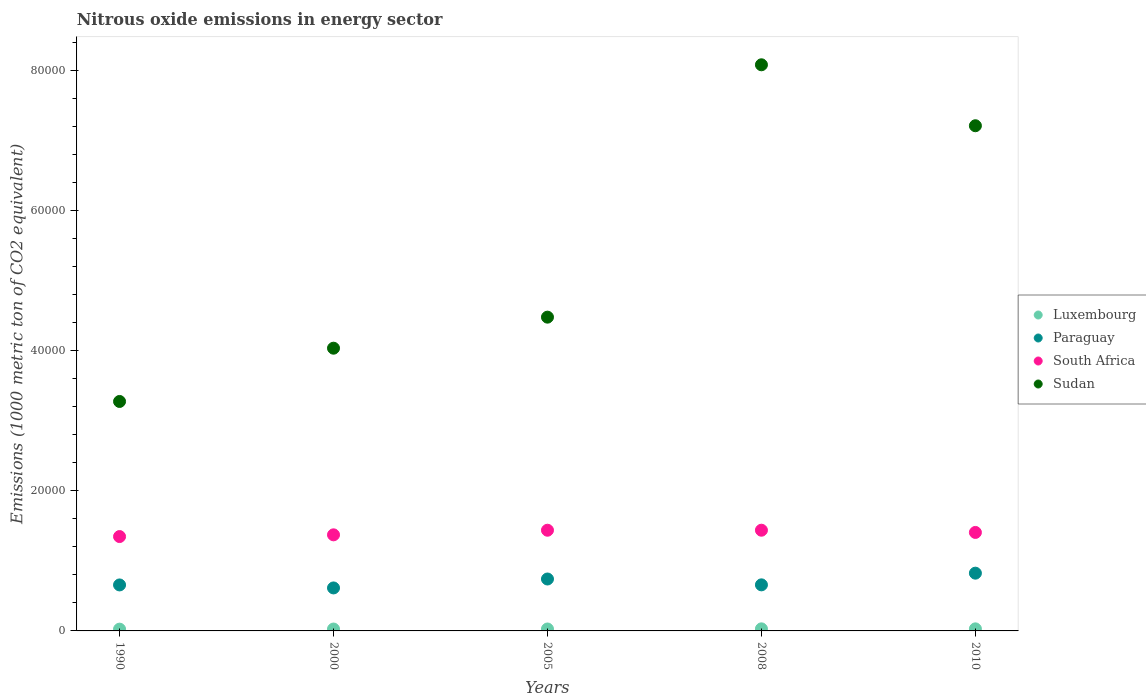Is the number of dotlines equal to the number of legend labels?
Provide a succinct answer. Yes. What is the amount of nitrous oxide emitted in Paraguay in 2010?
Provide a succinct answer. 8239.6. Across all years, what is the maximum amount of nitrous oxide emitted in Sudan?
Offer a very short reply. 8.08e+04. Across all years, what is the minimum amount of nitrous oxide emitted in South Africa?
Your answer should be very brief. 1.35e+04. What is the total amount of nitrous oxide emitted in South Africa in the graph?
Offer a terse response. 7.00e+04. What is the difference between the amount of nitrous oxide emitted in South Africa in 2005 and that in 2010?
Ensure brevity in your answer.  315.5. What is the difference between the amount of nitrous oxide emitted in Paraguay in 2005 and the amount of nitrous oxide emitted in Luxembourg in 2010?
Keep it short and to the point. 7113.5. What is the average amount of nitrous oxide emitted in Paraguay per year?
Your answer should be compact. 6982.86. In the year 1990, what is the difference between the amount of nitrous oxide emitted in South Africa and amount of nitrous oxide emitted in Sudan?
Offer a very short reply. -1.93e+04. What is the ratio of the amount of nitrous oxide emitted in Sudan in 1990 to that in 2010?
Offer a very short reply. 0.45. Is the difference between the amount of nitrous oxide emitted in South Africa in 2000 and 2010 greater than the difference between the amount of nitrous oxide emitted in Sudan in 2000 and 2010?
Make the answer very short. Yes. What is the difference between the highest and the second highest amount of nitrous oxide emitted in Luxembourg?
Your answer should be compact. 2. What is the difference between the highest and the lowest amount of nitrous oxide emitted in Paraguay?
Offer a terse response. 2106.8. In how many years, is the amount of nitrous oxide emitted in South Africa greater than the average amount of nitrous oxide emitted in South Africa taken over all years?
Your answer should be compact. 3. Is the sum of the amount of nitrous oxide emitted in Luxembourg in 2000 and 2005 greater than the maximum amount of nitrous oxide emitted in Sudan across all years?
Offer a terse response. No. Does the amount of nitrous oxide emitted in Luxembourg monotonically increase over the years?
Your answer should be compact. No. How many dotlines are there?
Provide a succinct answer. 4. Does the graph contain any zero values?
Your answer should be compact. No. Does the graph contain grids?
Ensure brevity in your answer.  No. Where does the legend appear in the graph?
Your response must be concise. Center right. How many legend labels are there?
Your answer should be very brief. 4. How are the legend labels stacked?
Make the answer very short. Vertical. What is the title of the graph?
Give a very brief answer. Nitrous oxide emissions in energy sector. Does "Middle East & North Africa (all income levels)" appear as one of the legend labels in the graph?
Your response must be concise. No. What is the label or title of the X-axis?
Give a very brief answer. Years. What is the label or title of the Y-axis?
Provide a short and direct response. Emissions (1000 metric ton of CO2 equivalent). What is the Emissions (1000 metric ton of CO2 equivalent) in Luxembourg in 1990?
Make the answer very short. 253.6. What is the Emissions (1000 metric ton of CO2 equivalent) of Paraguay in 1990?
Ensure brevity in your answer.  6561.2. What is the Emissions (1000 metric ton of CO2 equivalent) in South Africa in 1990?
Make the answer very short. 1.35e+04. What is the Emissions (1000 metric ton of CO2 equivalent) in Sudan in 1990?
Your response must be concise. 3.27e+04. What is the Emissions (1000 metric ton of CO2 equivalent) of Luxembourg in 2000?
Your answer should be compact. 268.4. What is the Emissions (1000 metric ton of CO2 equivalent) of Paraguay in 2000?
Your answer should be very brief. 6132.8. What is the Emissions (1000 metric ton of CO2 equivalent) in South Africa in 2000?
Offer a terse response. 1.37e+04. What is the Emissions (1000 metric ton of CO2 equivalent) in Sudan in 2000?
Your answer should be very brief. 4.03e+04. What is the Emissions (1000 metric ton of CO2 equivalent) in Luxembourg in 2005?
Offer a very short reply. 275.3. What is the Emissions (1000 metric ton of CO2 equivalent) of Paraguay in 2005?
Keep it short and to the point. 7407.7. What is the Emissions (1000 metric ton of CO2 equivalent) of South Africa in 2005?
Ensure brevity in your answer.  1.44e+04. What is the Emissions (1000 metric ton of CO2 equivalent) in Sudan in 2005?
Your response must be concise. 4.48e+04. What is the Emissions (1000 metric ton of CO2 equivalent) of Luxembourg in 2008?
Ensure brevity in your answer.  296.2. What is the Emissions (1000 metric ton of CO2 equivalent) in Paraguay in 2008?
Provide a succinct answer. 6573. What is the Emissions (1000 metric ton of CO2 equivalent) of South Africa in 2008?
Keep it short and to the point. 1.44e+04. What is the Emissions (1000 metric ton of CO2 equivalent) of Sudan in 2008?
Provide a succinct answer. 8.08e+04. What is the Emissions (1000 metric ton of CO2 equivalent) of Luxembourg in 2010?
Offer a terse response. 294.2. What is the Emissions (1000 metric ton of CO2 equivalent) in Paraguay in 2010?
Your answer should be very brief. 8239.6. What is the Emissions (1000 metric ton of CO2 equivalent) of South Africa in 2010?
Provide a succinct answer. 1.41e+04. What is the Emissions (1000 metric ton of CO2 equivalent) of Sudan in 2010?
Provide a succinct answer. 7.21e+04. Across all years, what is the maximum Emissions (1000 metric ton of CO2 equivalent) of Luxembourg?
Your answer should be very brief. 296.2. Across all years, what is the maximum Emissions (1000 metric ton of CO2 equivalent) of Paraguay?
Provide a short and direct response. 8239.6. Across all years, what is the maximum Emissions (1000 metric ton of CO2 equivalent) in South Africa?
Provide a succinct answer. 1.44e+04. Across all years, what is the maximum Emissions (1000 metric ton of CO2 equivalent) of Sudan?
Make the answer very short. 8.08e+04. Across all years, what is the minimum Emissions (1000 metric ton of CO2 equivalent) in Luxembourg?
Give a very brief answer. 253.6. Across all years, what is the minimum Emissions (1000 metric ton of CO2 equivalent) in Paraguay?
Your answer should be very brief. 6132.8. Across all years, what is the minimum Emissions (1000 metric ton of CO2 equivalent) of South Africa?
Offer a very short reply. 1.35e+04. Across all years, what is the minimum Emissions (1000 metric ton of CO2 equivalent) of Sudan?
Your answer should be very brief. 3.27e+04. What is the total Emissions (1000 metric ton of CO2 equivalent) of Luxembourg in the graph?
Your answer should be very brief. 1387.7. What is the total Emissions (1000 metric ton of CO2 equivalent) in Paraguay in the graph?
Ensure brevity in your answer.  3.49e+04. What is the total Emissions (1000 metric ton of CO2 equivalent) in South Africa in the graph?
Offer a terse response. 7.00e+04. What is the total Emissions (1000 metric ton of CO2 equivalent) in Sudan in the graph?
Give a very brief answer. 2.71e+05. What is the difference between the Emissions (1000 metric ton of CO2 equivalent) of Luxembourg in 1990 and that in 2000?
Provide a succinct answer. -14.8. What is the difference between the Emissions (1000 metric ton of CO2 equivalent) of Paraguay in 1990 and that in 2000?
Keep it short and to the point. 428.4. What is the difference between the Emissions (1000 metric ton of CO2 equivalent) of South Africa in 1990 and that in 2000?
Offer a terse response. -246.5. What is the difference between the Emissions (1000 metric ton of CO2 equivalent) of Sudan in 1990 and that in 2000?
Your response must be concise. -7600.6. What is the difference between the Emissions (1000 metric ton of CO2 equivalent) of Luxembourg in 1990 and that in 2005?
Your answer should be compact. -21.7. What is the difference between the Emissions (1000 metric ton of CO2 equivalent) of Paraguay in 1990 and that in 2005?
Provide a succinct answer. -846.5. What is the difference between the Emissions (1000 metric ton of CO2 equivalent) of South Africa in 1990 and that in 2005?
Provide a short and direct response. -903.7. What is the difference between the Emissions (1000 metric ton of CO2 equivalent) of Sudan in 1990 and that in 2005?
Keep it short and to the point. -1.20e+04. What is the difference between the Emissions (1000 metric ton of CO2 equivalent) in Luxembourg in 1990 and that in 2008?
Provide a succinct answer. -42.6. What is the difference between the Emissions (1000 metric ton of CO2 equivalent) in South Africa in 1990 and that in 2008?
Offer a very short reply. -905.7. What is the difference between the Emissions (1000 metric ton of CO2 equivalent) in Sudan in 1990 and that in 2008?
Your answer should be very brief. -4.80e+04. What is the difference between the Emissions (1000 metric ton of CO2 equivalent) in Luxembourg in 1990 and that in 2010?
Ensure brevity in your answer.  -40.6. What is the difference between the Emissions (1000 metric ton of CO2 equivalent) in Paraguay in 1990 and that in 2010?
Offer a very short reply. -1678.4. What is the difference between the Emissions (1000 metric ton of CO2 equivalent) in South Africa in 1990 and that in 2010?
Offer a very short reply. -588.2. What is the difference between the Emissions (1000 metric ton of CO2 equivalent) in Sudan in 1990 and that in 2010?
Provide a short and direct response. -3.93e+04. What is the difference between the Emissions (1000 metric ton of CO2 equivalent) in Luxembourg in 2000 and that in 2005?
Give a very brief answer. -6.9. What is the difference between the Emissions (1000 metric ton of CO2 equivalent) in Paraguay in 2000 and that in 2005?
Offer a very short reply. -1274.9. What is the difference between the Emissions (1000 metric ton of CO2 equivalent) in South Africa in 2000 and that in 2005?
Offer a very short reply. -657.2. What is the difference between the Emissions (1000 metric ton of CO2 equivalent) in Sudan in 2000 and that in 2005?
Give a very brief answer. -4429.1. What is the difference between the Emissions (1000 metric ton of CO2 equivalent) in Luxembourg in 2000 and that in 2008?
Offer a very short reply. -27.8. What is the difference between the Emissions (1000 metric ton of CO2 equivalent) in Paraguay in 2000 and that in 2008?
Provide a succinct answer. -440.2. What is the difference between the Emissions (1000 metric ton of CO2 equivalent) in South Africa in 2000 and that in 2008?
Your answer should be compact. -659.2. What is the difference between the Emissions (1000 metric ton of CO2 equivalent) of Sudan in 2000 and that in 2008?
Offer a very short reply. -4.04e+04. What is the difference between the Emissions (1000 metric ton of CO2 equivalent) of Luxembourg in 2000 and that in 2010?
Make the answer very short. -25.8. What is the difference between the Emissions (1000 metric ton of CO2 equivalent) in Paraguay in 2000 and that in 2010?
Keep it short and to the point. -2106.8. What is the difference between the Emissions (1000 metric ton of CO2 equivalent) of South Africa in 2000 and that in 2010?
Your answer should be compact. -341.7. What is the difference between the Emissions (1000 metric ton of CO2 equivalent) of Sudan in 2000 and that in 2010?
Make the answer very short. -3.17e+04. What is the difference between the Emissions (1000 metric ton of CO2 equivalent) of Luxembourg in 2005 and that in 2008?
Provide a succinct answer. -20.9. What is the difference between the Emissions (1000 metric ton of CO2 equivalent) in Paraguay in 2005 and that in 2008?
Ensure brevity in your answer.  834.7. What is the difference between the Emissions (1000 metric ton of CO2 equivalent) in South Africa in 2005 and that in 2008?
Make the answer very short. -2. What is the difference between the Emissions (1000 metric ton of CO2 equivalent) in Sudan in 2005 and that in 2008?
Make the answer very short. -3.60e+04. What is the difference between the Emissions (1000 metric ton of CO2 equivalent) of Luxembourg in 2005 and that in 2010?
Make the answer very short. -18.9. What is the difference between the Emissions (1000 metric ton of CO2 equivalent) in Paraguay in 2005 and that in 2010?
Make the answer very short. -831.9. What is the difference between the Emissions (1000 metric ton of CO2 equivalent) in South Africa in 2005 and that in 2010?
Make the answer very short. 315.5. What is the difference between the Emissions (1000 metric ton of CO2 equivalent) of Sudan in 2005 and that in 2010?
Give a very brief answer. -2.73e+04. What is the difference between the Emissions (1000 metric ton of CO2 equivalent) in Paraguay in 2008 and that in 2010?
Ensure brevity in your answer.  -1666.6. What is the difference between the Emissions (1000 metric ton of CO2 equivalent) of South Africa in 2008 and that in 2010?
Offer a terse response. 317.5. What is the difference between the Emissions (1000 metric ton of CO2 equivalent) in Sudan in 2008 and that in 2010?
Your answer should be compact. 8696.2. What is the difference between the Emissions (1000 metric ton of CO2 equivalent) in Luxembourg in 1990 and the Emissions (1000 metric ton of CO2 equivalent) in Paraguay in 2000?
Your response must be concise. -5879.2. What is the difference between the Emissions (1000 metric ton of CO2 equivalent) in Luxembourg in 1990 and the Emissions (1000 metric ton of CO2 equivalent) in South Africa in 2000?
Offer a very short reply. -1.35e+04. What is the difference between the Emissions (1000 metric ton of CO2 equivalent) of Luxembourg in 1990 and the Emissions (1000 metric ton of CO2 equivalent) of Sudan in 2000?
Provide a short and direct response. -4.01e+04. What is the difference between the Emissions (1000 metric ton of CO2 equivalent) of Paraguay in 1990 and the Emissions (1000 metric ton of CO2 equivalent) of South Africa in 2000?
Provide a succinct answer. -7148.7. What is the difference between the Emissions (1000 metric ton of CO2 equivalent) in Paraguay in 1990 and the Emissions (1000 metric ton of CO2 equivalent) in Sudan in 2000?
Your answer should be very brief. -3.38e+04. What is the difference between the Emissions (1000 metric ton of CO2 equivalent) of South Africa in 1990 and the Emissions (1000 metric ton of CO2 equivalent) of Sudan in 2000?
Your answer should be very brief. -2.69e+04. What is the difference between the Emissions (1000 metric ton of CO2 equivalent) of Luxembourg in 1990 and the Emissions (1000 metric ton of CO2 equivalent) of Paraguay in 2005?
Your response must be concise. -7154.1. What is the difference between the Emissions (1000 metric ton of CO2 equivalent) of Luxembourg in 1990 and the Emissions (1000 metric ton of CO2 equivalent) of South Africa in 2005?
Offer a very short reply. -1.41e+04. What is the difference between the Emissions (1000 metric ton of CO2 equivalent) in Luxembourg in 1990 and the Emissions (1000 metric ton of CO2 equivalent) in Sudan in 2005?
Keep it short and to the point. -4.45e+04. What is the difference between the Emissions (1000 metric ton of CO2 equivalent) in Paraguay in 1990 and the Emissions (1000 metric ton of CO2 equivalent) in South Africa in 2005?
Ensure brevity in your answer.  -7805.9. What is the difference between the Emissions (1000 metric ton of CO2 equivalent) in Paraguay in 1990 and the Emissions (1000 metric ton of CO2 equivalent) in Sudan in 2005?
Offer a terse response. -3.82e+04. What is the difference between the Emissions (1000 metric ton of CO2 equivalent) in South Africa in 1990 and the Emissions (1000 metric ton of CO2 equivalent) in Sudan in 2005?
Offer a very short reply. -3.13e+04. What is the difference between the Emissions (1000 metric ton of CO2 equivalent) in Luxembourg in 1990 and the Emissions (1000 metric ton of CO2 equivalent) in Paraguay in 2008?
Provide a succinct answer. -6319.4. What is the difference between the Emissions (1000 metric ton of CO2 equivalent) of Luxembourg in 1990 and the Emissions (1000 metric ton of CO2 equivalent) of South Africa in 2008?
Provide a short and direct response. -1.41e+04. What is the difference between the Emissions (1000 metric ton of CO2 equivalent) of Luxembourg in 1990 and the Emissions (1000 metric ton of CO2 equivalent) of Sudan in 2008?
Make the answer very short. -8.05e+04. What is the difference between the Emissions (1000 metric ton of CO2 equivalent) of Paraguay in 1990 and the Emissions (1000 metric ton of CO2 equivalent) of South Africa in 2008?
Your response must be concise. -7807.9. What is the difference between the Emissions (1000 metric ton of CO2 equivalent) in Paraguay in 1990 and the Emissions (1000 metric ton of CO2 equivalent) in Sudan in 2008?
Offer a terse response. -7.42e+04. What is the difference between the Emissions (1000 metric ton of CO2 equivalent) of South Africa in 1990 and the Emissions (1000 metric ton of CO2 equivalent) of Sudan in 2008?
Your response must be concise. -6.73e+04. What is the difference between the Emissions (1000 metric ton of CO2 equivalent) in Luxembourg in 1990 and the Emissions (1000 metric ton of CO2 equivalent) in Paraguay in 2010?
Provide a short and direct response. -7986. What is the difference between the Emissions (1000 metric ton of CO2 equivalent) in Luxembourg in 1990 and the Emissions (1000 metric ton of CO2 equivalent) in South Africa in 2010?
Offer a terse response. -1.38e+04. What is the difference between the Emissions (1000 metric ton of CO2 equivalent) of Luxembourg in 1990 and the Emissions (1000 metric ton of CO2 equivalent) of Sudan in 2010?
Keep it short and to the point. -7.18e+04. What is the difference between the Emissions (1000 metric ton of CO2 equivalent) in Paraguay in 1990 and the Emissions (1000 metric ton of CO2 equivalent) in South Africa in 2010?
Provide a short and direct response. -7490.4. What is the difference between the Emissions (1000 metric ton of CO2 equivalent) in Paraguay in 1990 and the Emissions (1000 metric ton of CO2 equivalent) in Sudan in 2010?
Provide a short and direct response. -6.55e+04. What is the difference between the Emissions (1000 metric ton of CO2 equivalent) in South Africa in 1990 and the Emissions (1000 metric ton of CO2 equivalent) in Sudan in 2010?
Ensure brevity in your answer.  -5.86e+04. What is the difference between the Emissions (1000 metric ton of CO2 equivalent) of Luxembourg in 2000 and the Emissions (1000 metric ton of CO2 equivalent) of Paraguay in 2005?
Make the answer very short. -7139.3. What is the difference between the Emissions (1000 metric ton of CO2 equivalent) in Luxembourg in 2000 and the Emissions (1000 metric ton of CO2 equivalent) in South Africa in 2005?
Ensure brevity in your answer.  -1.41e+04. What is the difference between the Emissions (1000 metric ton of CO2 equivalent) of Luxembourg in 2000 and the Emissions (1000 metric ton of CO2 equivalent) of Sudan in 2005?
Offer a terse response. -4.45e+04. What is the difference between the Emissions (1000 metric ton of CO2 equivalent) in Paraguay in 2000 and the Emissions (1000 metric ton of CO2 equivalent) in South Africa in 2005?
Your answer should be compact. -8234.3. What is the difference between the Emissions (1000 metric ton of CO2 equivalent) in Paraguay in 2000 and the Emissions (1000 metric ton of CO2 equivalent) in Sudan in 2005?
Your answer should be very brief. -3.86e+04. What is the difference between the Emissions (1000 metric ton of CO2 equivalent) in South Africa in 2000 and the Emissions (1000 metric ton of CO2 equivalent) in Sudan in 2005?
Ensure brevity in your answer.  -3.11e+04. What is the difference between the Emissions (1000 metric ton of CO2 equivalent) in Luxembourg in 2000 and the Emissions (1000 metric ton of CO2 equivalent) in Paraguay in 2008?
Provide a succinct answer. -6304.6. What is the difference between the Emissions (1000 metric ton of CO2 equivalent) of Luxembourg in 2000 and the Emissions (1000 metric ton of CO2 equivalent) of South Africa in 2008?
Make the answer very short. -1.41e+04. What is the difference between the Emissions (1000 metric ton of CO2 equivalent) of Luxembourg in 2000 and the Emissions (1000 metric ton of CO2 equivalent) of Sudan in 2008?
Make the answer very short. -8.05e+04. What is the difference between the Emissions (1000 metric ton of CO2 equivalent) in Paraguay in 2000 and the Emissions (1000 metric ton of CO2 equivalent) in South Africa in 2008?
Give a very brief answer. -8236.3. What is the difference between the Emissions (1000 metric ton of CO2 equivalent) in Paraguay in 2000 and the Emissions (1000 metric ton of CO2 equivalent) in Sudan in 2008?
Your response must be concise. -7.46e+04. What is the difference between the Emissions (1000 metric ton of CO2 equivalent) of South Africa in 2000 and the Emissions (1000 metric ton of CO2 equivalent) of Sudan in 2008?
Keep it short and to the point. -6.71e+04. What is the difference between the Emissions (1000 metric ton of CO2 equivalent) of Luxembourg in 2000 and the Emissions (1000 metric ton of CO2 equivalent) of Paraguay in 2010?
Offer a terse response. -7971.2. What is the difference between the Emissions (1000 metric ton of CO2 equivalent) in Luxembourg in 2000 and the Emissions (1000 metric ton of CO2 equivalent) in South Africa in 2010?
Provide a short and direct response. -1.38e+04. What is the difference between the Emissions (1000 metric ton of CO2 equivalent) of Luxembourg in 2000 and the Emissions (1000 metric ton of CO2 equivalent) of Sudan in 2010?
Your answer should be compact. -7.18e+04. What is the difference between the Emissions (1000 metric ton of CO2 equivalent) of Paraguay in 2000 and the Emissions (1000 metric ton of CO2 equivalent) of South Africa in 2010?
Your answer should be very brief. -7918.8. What is the difference between the Emissions (1000 metric ton of CO2 equivalent) of Paraguay in 2000 and the Emissions (1000 metric ton of CO2 equivalent) of Sudan in 2010?
Offer a very short reply. -6.59e+04. What is the difference between the Emissions (1000 metric ton of CO2 equivalent) in South Africa in 2000 and the Emissions (1000 metric ton of CO2 equivalent) in Sudan in 2010?
Provide a short and direct response. -5.84e+04. What is the difference between the Emissions (1000 metric ton of CO2 equivalent) of Luxembourg in 2005 and the Emissions (1000 metric ton of CO2 equivalent) of Paraguay in 2008?
Keep it short and to the point. -6297.7. What is the difference between the Emissions (1000 metric ton of CO2 equivalent) in Luxembourg in 2005 and the Emissions (1000 metric ton of CO2 equivalent) in South Africa in 2008?
Provide a succinct answer. -1.41e+04. What is the difference between the Emissions (1000 metric ton of CO2 equivalent) in Luxembourg in 2005 and the Emissions (1000 metric ton of CO2 equivalent) in Sudan in 2008?
Offer a very short reply. -8.05e+04. What is the difference between the Emissions (1000 metric ton of CO2 equivalent) of Paraguay in 2005 and the Emissions (1000 metric ton of CO2 equivalent) of South Africa in 2008?
Your response must be concise. -6961.4. What is the difference between the Emissions (1000 metric ton of CO2 equivalent) of Paraguay in 2005 and the Emissions (1000 metric ton of CO2 equivalent) of Sudan in 2008?
Your response must be concise. -7.34e+04. What is the difference between the Emissions (1000 metric ton of CO2 equivalent) of South Africa in 2005 and the Emissions (1000 metric ton of CO2 equivalent) of Sudan in 2008?
Provide a short and direct response. -6.64e+04. What is the difference between the Emissions (1000 metric ton of CO2 equivalent) in Luxembourg in 2005 and the Emissions (1000 metric ton of CO2 equivalent) in Paraguay in 2010?
Offer a very short reply. -7964.3. What is the difference between the Emissions (1000 metric ton of CO2 equivalent) in Luxembourg in 2005 and the Emissions (1000 metric ton of CO2 equivalent) in South Africa in 2010?
Give a very brief answer. -1.38e+04. What is the difference between the Emissions (1000 metric ton of CO2 equivalent) of Luxembourg in 2005 and the Emissions (1000 metric ton of CO2 equivalent) of Sudan in 2010?
Provide a succinct answer. -7.18e+04. What is the difference between the Emissions (1000 metric ton of CO2 equivalent) of Paraguay in 2005 and the Emissions (1000 metric ton of CO2 equivalent) of South Africa in 2010?
Your answer should be very brief. -6643.9. What is the difference between the Emissions (1000 metric ton of CO2 equivalent) in Paraguay in 2005 and the Emissions (1000 metric ton of CO2 equivalent) in Sudan in 2010?
Keep it short and to the point. -6.47e+04. What is the difference between the Emissions (1000 metric ton of CO2 equivalent) of South Africa in 2005 and the Emissions (1000 metric ton of CO2 equivalent) of Sudan in 2010?
Keep it short and to the point. -5.77e+04. What is the difference between the Emissions (1000 metric ton of CO2 equivalent) of Luxembourg in 2008 and the Emissions (1000 metric ton of CO2 equivalent) of Paraguay in 2010?
Provide a succinct answer. -7943.4. What is the difference between the Emissions (1000 metric ton of CO2 equivalent) in Luxembourg in 2008 and the Emissions (1000 metric ton of CO2 equivalent) in South Africa in 2010?
Your response must be concise. -1.38e+04. What is the difference between the Emissions (1000 metric ton of CO2 equivalent) of Luxembourg in 2008 and the Emissions (1000 metric ton of CO2 equivalent) of Sudan in 2010?
Offer a very short reply. -7.18e+04. What is the difference between the Emissions (1000 metric ton of CO2 equivalent) in Paraguay in 2008 and the Emissions (1000 metric ton of CO2 equivalent) in South Africa in 2010?
Keep it short and to the point. -7478.6. What is the difference between the Emissions (1000 metric ton of CO2 equivalent) of Paraguay in 2008 and the Emissions (1000 metric ton of CO2 equivalent) of Sudan in 2010?
Ensure brevity in your answer.  -6.55e+04. What is the difference between the Emissions (1000 metric ton of CO2 equivalent) of South Africa in 2008 and the Emissions (1000 metric ton of CO2 equivalent) of Sudan in 2010?
Provide a short and direct response. -5.77e+04. What is the average Emissions (1000 metric ton of CO2 equivalent) in Luxembourg per year?
Offer a terse response. 277.54. What is the average Emissions (1000 metric ton of CO2 equivalent) in Paraguay per year?
Your answer should be compact. 6982.86. What is the average Emissions (1000 metric ton of CO2 equivalent) in South Africa per year?
Provide a short and direct response. 1.40e+04. What is the average Emissions (1000 metric ton of CO2 equivalent) in Sudan per year?
Ensure brevity in your answer.  5.41e+04. In the year 1990, what is the difference between the Emissions (1000 metric ton of CO2 equivalent) of Luxembourg and Emissions (1000 metric ton of CO2 equivalent) of Paraguay?
Give a very brief answer. -6307.6. In the year 1990, what is the difference between the Emissions (1000 metric ton of CO2 equivalent) of Luxembourg and Emissions (1000 metric ton of CO2 equivalent) of South Africa?
Your answer should be compact. -1.32e+04. In the year 1990, what is the difference between the Emissions (1000 metric ton of CO2 equivalent) in Luxembourg and Emissions (1000 metric ton of CO2 equivalent) in Sudan?
Keep it short and to the point. -3.25e+04. In the year 1990, what is the difference between the Emissions (1000 metric ton of CO2 equivalent) in Paraguay and Emissions (1000 metric ton of CO2 equivalent) in South Africa?
Keep it short and to the point. -6902.2. In the year 1990, what is the difference between the Emissions (1000 metric ton of CO2 equivalent) in Paraguay and Emissions (1000 metric ton of CO2 equivalent) in Sudan?
Your response must be concise. -2.62e+04. In the year 1990, what is the difference between the Emissions (1000 metric ton of CO2 equivalent) of South Africa and Emissions (1000 metric ton of CO2 equivalent) of Sudan?
Make the answer very short. -1.93e+04. In the year 2000, what is the difference between the Emissions (1000 metric ton of CO2 equivalent) of Luxembourg and Emissions (1000 metric ton of CO2 equivalent) of Paraguay?
Your answer should be very brief. -5864.4. In the year 2000, what is the difference between the Emissions (1000 metric ton of CO2 equivalent) of Luxembourg and Emissions (1000 metric ton of CO2 equivalent) of South Africa?
Offer a terse response. -1.34e+04. In the year 2000, what is the difference between the Emissions (1000 metric ton of CO2 equivalent) in Luxembourg and Emissions (1000 metric ton of CO2 equivalent) in Sudan?
Keep it short and to the point. -4.01e+04. In the year 2000, what is the difference between the Emissions (1000 metric ton of CO2 equivalent) in Paraguay and Emissions (1000 metric ton of CO2 equivalent) in South Africa?
Provide a succinct answer. -7577.1. In the year 2000, what is the difference between the Emissions (1000 metric ton of CO2 equivalent) in Paraguay and Emissions (1000 metric ton of CO2 equivalent) in Sudan?
Offer a very short reply. -3.42e+04. In the year 2000, what is the difference between the Emissions (1000 metric ton of CO2 equivalent) in South Africa and Emissions (1000 metric ton of CO2 equivalent) in Sudan?
Give a very brief answer. -2.66e+04. In the year 2005, what is the difference between the Emissions (1000 metric ton of CO2 equivalent) in Luxembourg and Emissions (1000 metric ton of CO2 equivalent) in Paraguay?
Offer a very short reply. -7132.4. In the year 2005, what is the difference between the Emissions (1000 metric ton of CO2 equivalent) of Luxembourg and Emissions (1000 metric ton of CO2 equivalent) of South Africa?
Ensure brevity in your answer.  -1.41e+04. In the year 2005, what is the difference between the Emissions (1000 metric ton of CO2 equivalent) in Luxembourg and Emissions (1000 metric ton of CO2 equivalent) in Sudan?
Your answer should be compact. -4.45e+04. In the year 2005, what is the difference between the Emissions (1000 metric ton of CO2 equivalent) in Paraguay and Emissions (1000 metric ton of CO2 equivalent) in South Africa?
Provide a succinct answer. -6959.4. In the year 2005, what is the difference between the Emissions (1000 metric ton of CO2 equivalent) of Paraguay and Emissions (1000 metric ton of CO2 equivalent) of Sudan?
Your answer should be compact. -3.74e+04. In the year 2005, what is the difference between the Emissions (1000 metric ton of CO2 equivalent) of South Africa and Emissions (1000 metric ton of CO2 equivalent) of Sudan?
Provide a succinct answer. -3.04e+04. In the year 2008, what is the difference between the Emissions (1000 metric ton of CO2 equivalent) in Luxembourg and Emissions (1000 metric ton of CO2 equivalent) in Paraguay?
Make the answer very short. -6276.8. In the year 2008, what is the difference between the Emissions (1000 metric ton of CO2 equivalent) in Luxembourg and Emissions (1000 metric ton of CO2 equivalent) in South Africa?
Your answer should be compact. -1.41e+04. In the year 2008, what is the difference between the Emissions (1000 metric ton of CO2 equivalent) of Luxembourg and Emissions (1000 metric ton of CO2 equivalent) of Sudan?
Your response must be concise. -8.05e+04. In the year 2008, what is the difference between the Emissions (1000 metric ton of CO2 equivalent) in Paraguay and Emissions (1000 metric ton of CO2 equivalent) in South Africa?
Give a very brief answer. -7796.1. In the year 2008, what is the difference between the Emissions (1000 metric ton of CO2 equivalent) in Paraguay and Emissions (1000 metric ton of CO2 equivalent) in Sudan?
Your response must be concise. -7.42e+04. In the year 2008, what is the difference between the Emissions (1000 metric ton of CO2 equivalent) in South Africa and Emissions (1000 metric ton of CO2 equivalent) in Sudan?
Give a very brief answer. -6.64e+04. In the year 2010, what is the difference between the Emissions (1000 metric ton of CO2 equivalent) of Luxembourg and Emissions (1000 metric ton of CO2 equivalent) of Paraguay?
Offer a terse response. -7945.4. In the year 2010, what is the difference between the Emissions (1000 metric ton of CO2 equivalent) in Luxembourg and Emissions (1000 metric ton of CO2 equivalent) in South Africa?
Your answer should be compact. -1.38e+04. In the year 2010, what is the difference between the Emissions (1000 metric ton of CO2 equivalent) of Luxembourg and Emissions (1000 metric ton of CO2 equivalent) of Sudan?
Ensure brevity in your answer.  -7.18e+04. In the year 2010, what is the difference between the Emissions (1000 metric ton of CO2 equivalent) in Paraguay and Emissions (1000 metric ton of CO2 equivalent) in South Africa?
Ensure brevity in your answer.  -5812. In the year 2010, what is the difference between the Emissions (1000 metric ton of CO2 equivalent) of Paraguay and Emissions (1000 metric ton of CO2 equivalent) of Sudan?
Make the answer very short. -6.38e+04. In the year 2010, what is the difference between the Emissions (1000 metric ton of CO2 equivalent) in South Africa and Emissions (1000 metric ton of CO2 equivalent) in Sudan?
Your answer should be compact. -5.80e+04. What is the ratio of the Emissions (1000 metric ton of CO2 equivalent) in Luxembourg in 1990 to that in 2000?
Your answer should be very brief. 0.94. What is the ratio of the Emissions (1000 metric ton of CO2 equivalent) of Paraguay in 1990 to that in 2000?
Ensure brevity in your answer.  1.07. What is the ratio of the Emissions (1000 metric ton of CO2 equivalent) of South Africa in 1990 to that in 2000?
Ensure brevity in your answer.  0.98. What is the ratio of the Emissions (1000 metric ton of CO2 equivalent) in Sudan in 1990 to that in 2000?
Make the answer very short. 0.81. What is the ratio of the Emissions (1000 metric ton of CO2 equivalent) of Luxembourg in 1990 to that in 2005?
Offer a terse response. 0.92. What is the ratio of the Emissions (1000 metric ton of CO2 equivalent) in Paraguay in 1990 to that in 2005?
Ensure brevity in your answer.  0.89. What is the ratio of the Emissions (1000 metric ton of CO2 equivalent) of South Africa in 1990 to that in 2005?
Make the answer very short. 0.94. What is the ratio of the Emissions (1000 metric ton of CO2 equivalent) of Sudan in 1990 to that in 2005?
Your answer should be compact. 0.73. What is the ratio of the Emissions (1000 metric ton of CO2 equivalent) in Luxembourg in 1990 to that in 2008?
Make the answer very short. 0.86. What is the ratio of the Emissions (1000 metric ton of CO2 equivalent) in South Africa in 1990 to that in 2008?
Your answer should be compact. 0.94. What is the ratio of the Emissions (1000 metric ton of CO2 equivalent) in Sudan in 1990 to that in 2008?
Your answer should be very brief. 0.41. What is the ratio of the Emissions (1000 metric ton of CO2 equivalent) of Luxembourg in 1990 to that in 2010?
Your answer should be very brief. 0.86. What is the ratio of the Emissions (1000 metric ton of CO2 equivalent) of Paraguay in 1990 to that in 2010?
Give a very brief answer. 0.8. What is the ratio of the Emissions (1000 metric ton of CO2 equivalent) in South Africa in 1990 to that in 2010?
Offer a terse response. 0.96. What is the ratio of the Emissions (1000 metric ton of CO2 equivalent) of Sudan in 1990 to that in 2010?
Your answer should be very brief. 0.45. What is the ratio of the Emissions (1000 metric ton of CO2 equivalent) in Luxembourg in 2000 to that in 2005?
Your answer should be compact. 0.97. What is the ratio of the Emissions (1000 metric ton of CO2 equivalent) of Paraguay in 2000 to that in 2005?
Ensure brevity in your answer.  0.83. What is the ratio of the Emissions (1000 metric ton of CO2 equivalent) in South Africa in 2000 to that in 2005?
Offer a terse response. 0.95. What is the ratio of the Emissions (1000 metric ton of CO2 equivalent) of Sudan in 2000 to that in 2005?
Ensure brevity in your answer.  0.9. What is the ratio of the Emissions (1000 metric ton of CO2 equivalent) in Luxembourg in 2000 to that in 2008?
Your answer should be compact. 0.91. What is the ratio of the Emissions (1000 metric ton of CO2 equivalent) in Paraguay in 2000 to that in 2008?
Provide a succinct answer. 0.93. What is the ratio of the Emissions (1000 metric ton of CO2 equivalent) of South Africa in 2000 to that in 2008?
Keep it short and to the point. 0.95. What is the ratio of the Emissions (1000 metric ton of CO2 equivalent) in Sudan in 2000 to that in 2008?
Your answer should be compact. 0.5. What is the ratio of the Emissions (1000 metric ton of CO2 equivalent) of Luxembourg in 2000 to that in 2010?
Your answer should be compact. 0.91. What is the ratio of the Emissions (1000 metric ton of CO2 equivalent) in Paraguay in 2000 to that in 2010?
Your answer should be very brief. 0.74. What is the ratio of the Emissions (1000 metric ton of CO2 equivalent) of South Africa in 2000 to that in 2010?
Your answer should be compact. 0.98. What is the ratio of the Emissions (1000 metric ton of CO2 equivalent) in Sudan in 2000 to that in 2010?
Provide a short and direct response. 0.56. What is the ratio of the Emissions (1000 metric ton of CO2 equivalent) of Luxembourg in 2005 to that in 2008?
Offer a very short reply. 0.93. What is the ratio of the Emissions (1000 metric ton of CO2 equivalent) in Paraguay in 2005 to that in 2008?
Keep it short and to the point. 1.13. What is the ratio of the Emissions (1000 metric ton of CO2 equivalent) in Sudan in 2005 to that in 2008?
Offer a terse response. 0.55. What is the ratio of the Emissions (1000 metric ton of CO2 equivalent) of Luxembourg in 2005 to that in 2010?
Offer a very short reply. 0.94. What is the ratio of the Emissions (1000 metric ton of CO2 equivalent) in Paraguay in 2005 to that in 2010?
Your answer should be very brief. 0.9. What is the ratio of the Emissions (1000 metric ton of CO2 equivalent) of South Africa in 2005 to that in 2010?
Your answer should be compact. 1.02. What is the ratio of the Emissions (1000 metric ton of CO2 equivalent) of Sudan in 2005 to that in 2010?
Keep it short and to the point. 0.62. What is the ratio of the Emissions (1000 metric ton of CO2 equivalent) in Luxembourg in 2008 to that in 2010?
Keep it short and to the point. 1.01. What is the ratio of the Emissions (1000 metric ton of CO2 equivalent) in Paraguay in 2008 to that in 2010?
Ensure brevity in your answer.  0.8. What is the ratio of the Emissions (1000 metric ton of CO2 equivalent) of South Africa in 2008 to that in 2010?
Ensure brevity in your answer.  1.02. What is the ratio of the Emissions (1000 metric ton of CO2 equivalent) of Sudan in 2008 to that in 2010?
Ensure brevity in your answer.  1.12. What is the difference between the highest and the second highest Emissions (1000 metric ton of CO2 equivalent) of Luxembourg?
Offer a terse response. 2. What is the difference between the highest and the second highest Emissions (1000 metric ton of CO2 equivalent) in Paraguay?
Provide a short and direct response. 831.9. What is the difference between the highest and the second highest Emissions (1000 metric ton of CO2 equivalent) of South Africa?
Give a very brief answer. 2. What is the difference between the highest and the second highest Emissions (1000 metric ton of CO2 equivalent) of Sudan?
Your answer should be very brief. 8696.2. What is the difference between the highest and the lowest Emissions (1000 metric ton of CO2 equivalent) of Luxembourg?
Offer a very short reply. 42.6. What is the difference between the highest and the lowest Emissions (1000 metric ton of CO2 equivalent) of Paraguay?
Provide a succinct answer. 2106.8. What is the difference between the highest and the lowest Emissions (1000 metric ton of CO2 equivalent) in South Africa?
Provide a short and direct response. 905.7. What is the difference between the highest and the lowest Emissions (1000 metric ton of CO2 equivalent) of Sudan?
Give a very brief answer. 4.80e+04. 